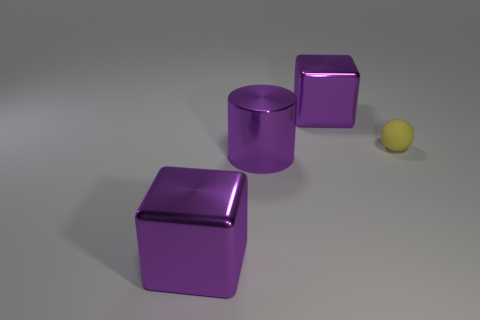How many objects are in this image, and can you describe their colors and materials? There are four objects in the image. Starting from the left, we have a large, reflective purple cube, likely made of a polished plastic or perhaps metal. Next is a shiny purple cylinder that shares the same color and material characteristics. To the right, there is another cube, smaller than the first, with the same purple color and reflective surface. Finally, there is a small, matte-finished yellow sphere that seems to be made of a rubber-like material. 